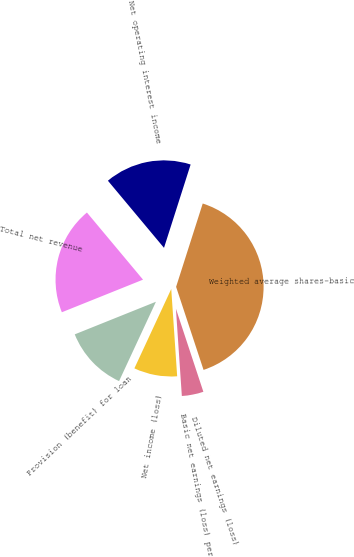Convert chart to OTSL. <chart><loc_0><loc_0><loc_500><loc_500><pie_chart><fcel>Net operating interest income<fcel>Total net revenue<fcel>Provision (benefit) for loan<fcel>Net income (loss)<fcel>Basic net earnings (loss) per<fcel>Diluted net earnings (loss)<fcel>Weighted average shares-basic<nl><fcel>16.0%<fcel>20.0%<fcel>12.0%<fcel>8.0%<fcel>4.0%<fcel>0.0%<fcel>40.0%<nl></chart> 